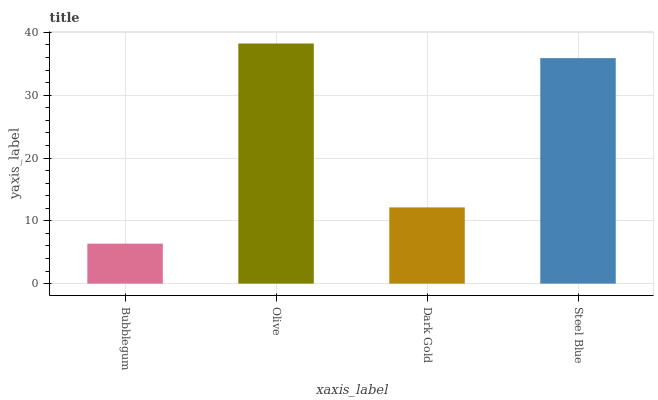Is Bubblegum the minimum?
Answer yes or no. Yes. Is Olive the maximum?
Answer yes or no. Yes. Is Dark Gold the minimum?
Answer yes or no. No. Is Dark Gold the maximum?
Answer yes or no. No. Is Olive greater than Dark Gold?
Answer yes or no. Yes. Is Dark Gold less than Olive?
Answer yes or no. Yes. Is Dark Gold greater than Olive?
Answer yes or no. No. Is Olive less than Dark Gold?
Answer yes or no. No. Is Steel Blue the high median?
Answer yes or no. Yes. Is Dark Gold the low median?
Answer yes or no. Yes. Is Dark Gold the high median?
Answer yes or no. No. Is Olive the low median?
Answer yes or no. No. 